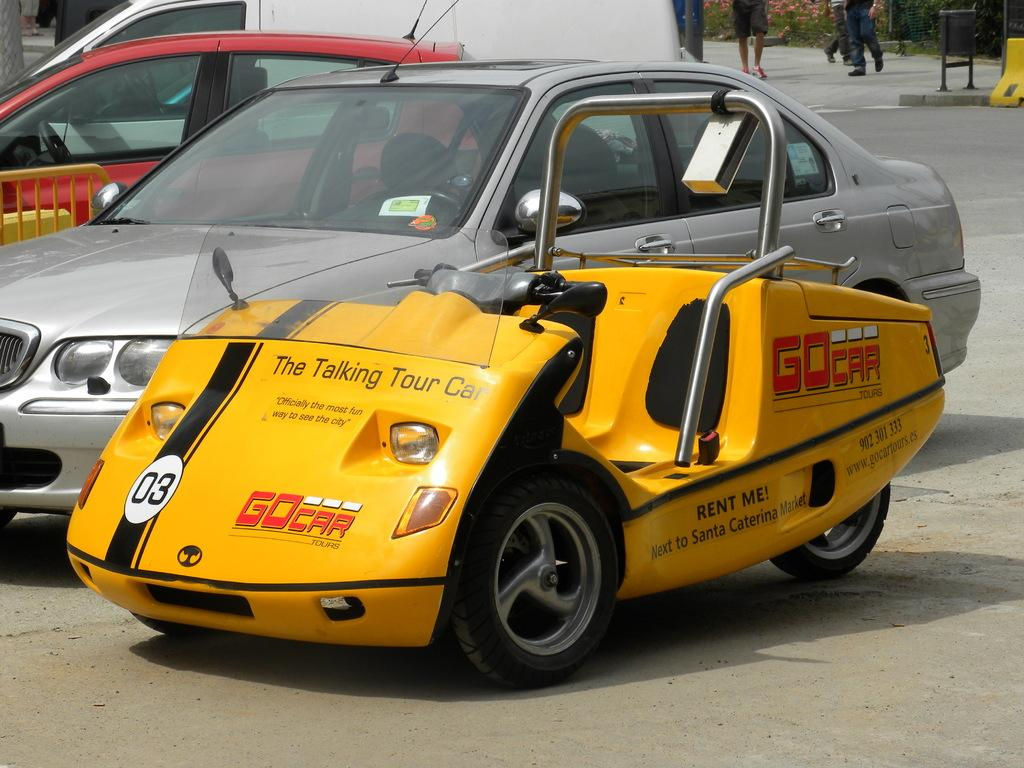<image>
Create a compact narrative representing the image presented. The talking tour car can be rented and is in the parking lot. 